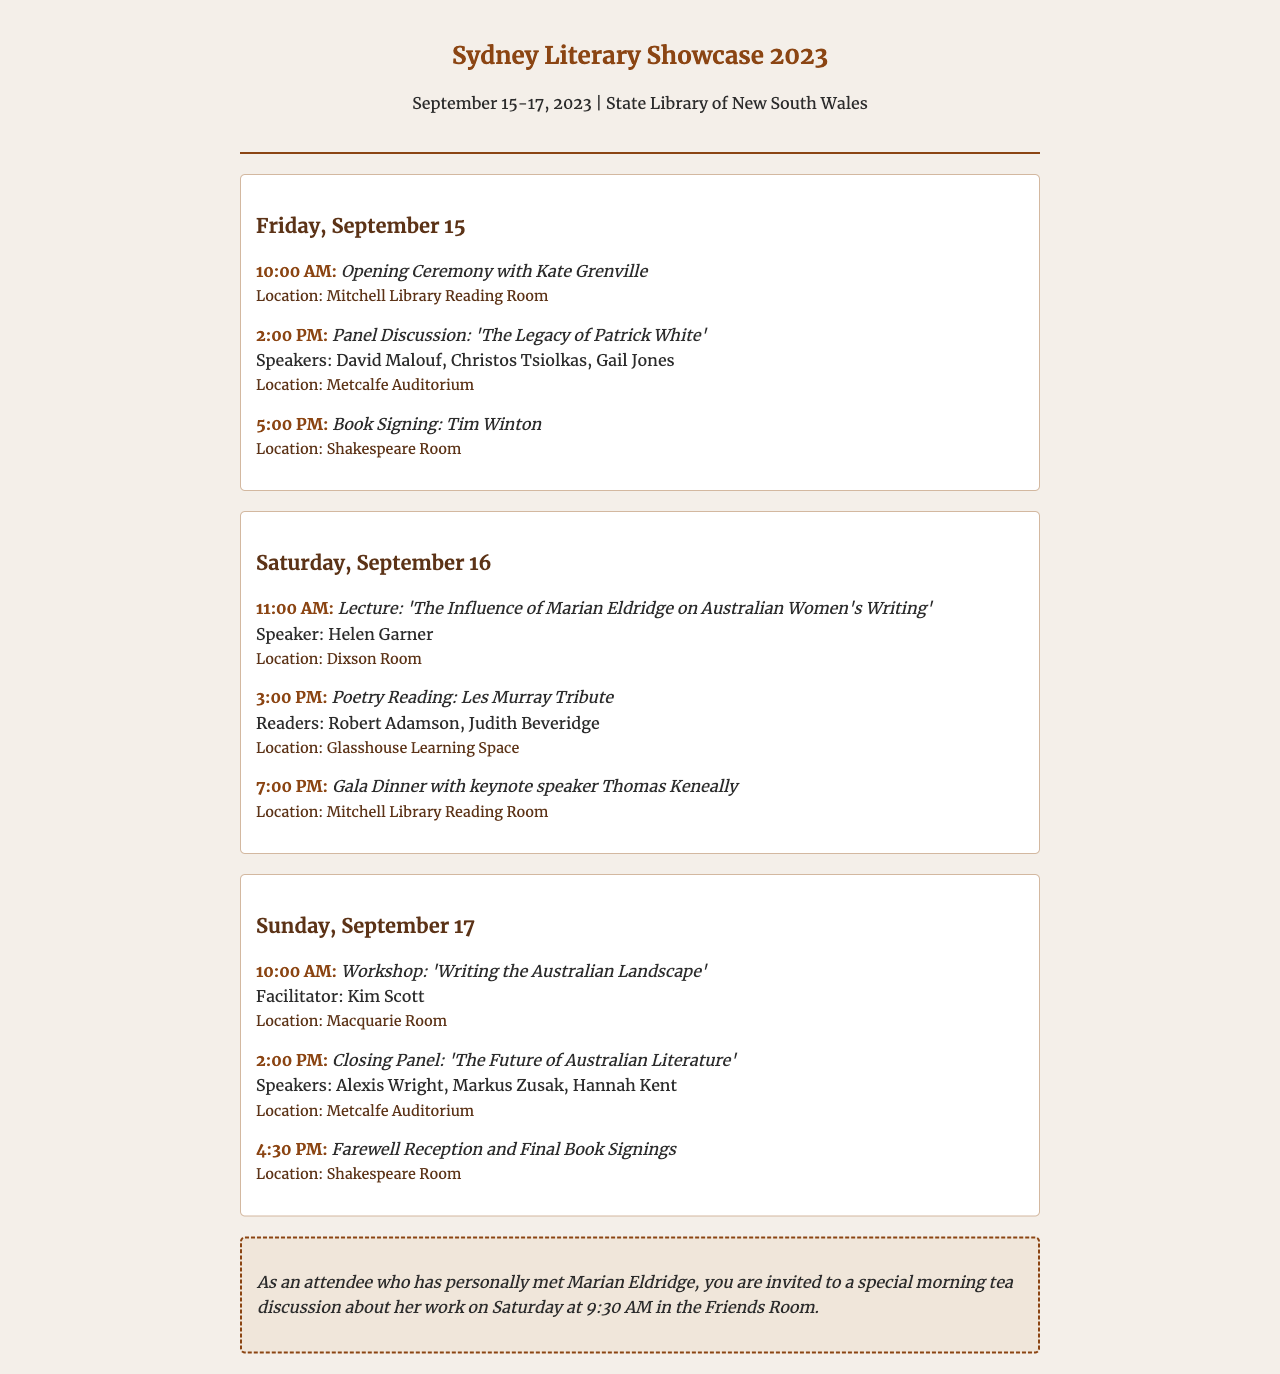what is the date range of the festival? The date range is provided in the first paragraph as September 15-17, 2023.
Answer: September 15-17, 2023 who is the keynote speaker at the Gala Dinner? The document lists Thomas Keneally as the keynote speaker for the Gala Dinner on Saturday.
Answer: Thomas Keneally which room hosts the Opening Ceremony? The document specifies that the Opening Ceremony takes place in the Mitchell Library Reading Room.
Answer: Mitchell Library Reading Room how many speakers are present at the Closing Panel? The Closing Panel features three speakers as indicated in the event details.
Answer: Three what is the unique offer for attendees who met Marian Eldridge? A special morning tea discussion about her work is offered to those attendees.
Answer: Special morning tea discussion what time does the farewell reception begin? The document provides the start time for the farewell reception as 4:30 PM.
Answer: 4:30 PM who facilitates the workshop on Writing the Australian Landscape? The facilitator's name is mentioned in the workshop details as Kim Scott.
Answer: Kim Scott which location holds the panel discussion about Patrick White? The event details state that the panel discussion is located in the Metcalfe Auditorium.
Answer: Metcalfe Auditorium what type of event is scheduled at 2:00 PM on Friday? The event at that time is a Panel Discussion, as indicated in the schedule.
Answer: Panel Discussion 